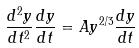Convert formula to latex. <formula><loc_0><loc_0><loc_500><loc_500>\frac { d ^ { 2 } y } { d t ^ { 2 } } \frac { d y } { d t } = A y ^ { 2 / 3 } \frac { d y } { d t }</formula> 